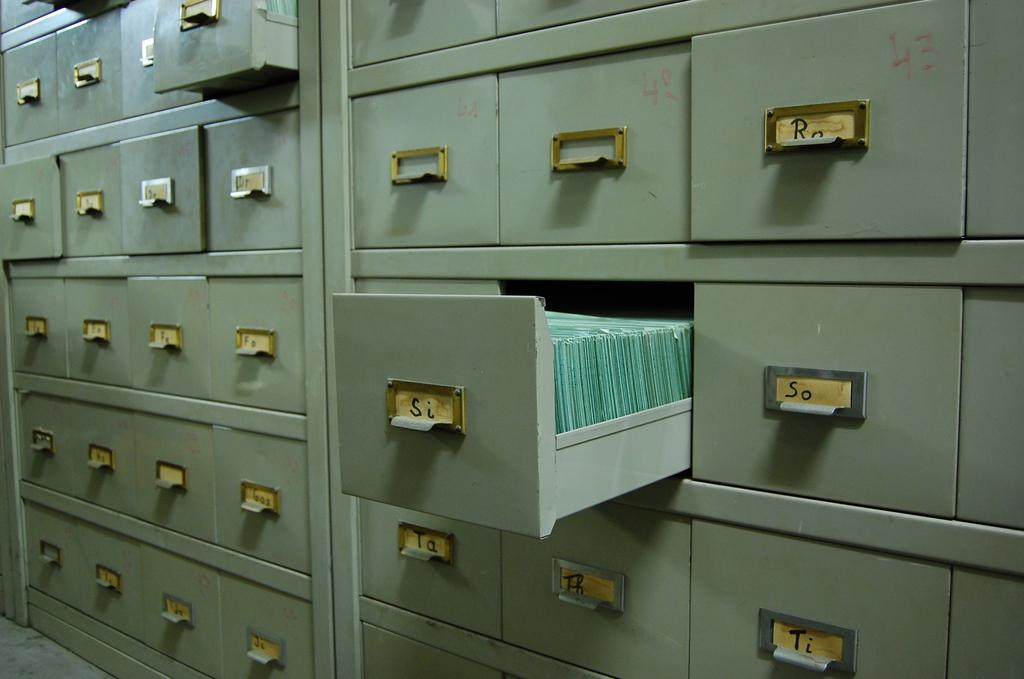What type of storage units are present in the image? There are lockers in the image. Are all the lockers closed, or are some of them opened? Some of the lockers are opened. What type of vehicle is parked next to the lockers in the image? There is no vehicle present in the image; it only features lockers. What type of cooking appliance can be seen in the image? There is no cooking appliance present in the image; it only features lockers. 